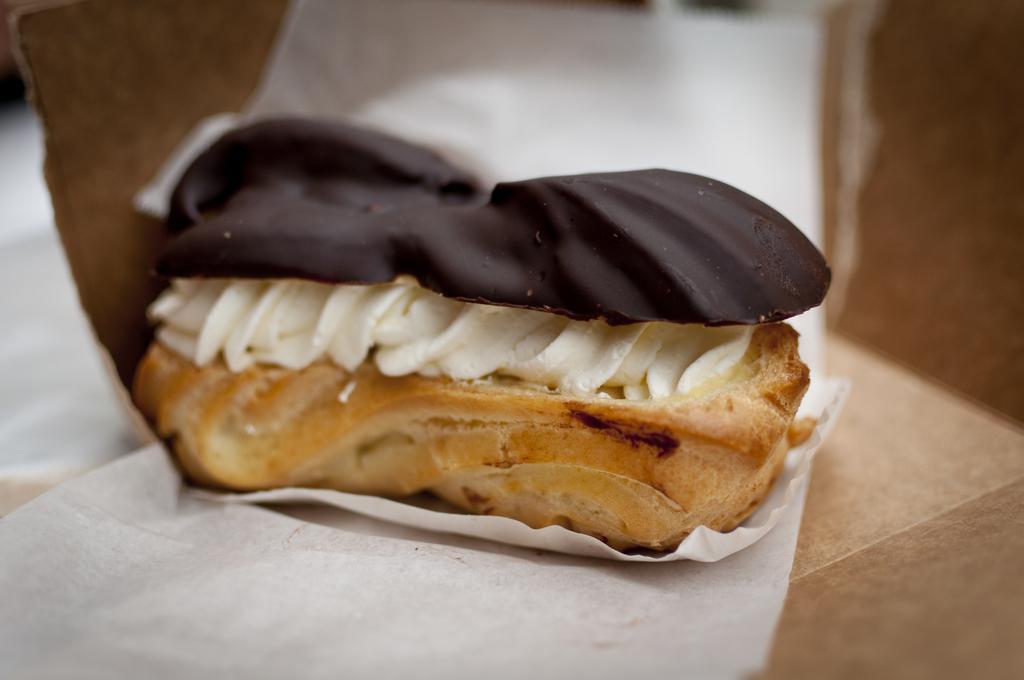How would you summarize this image in a sentence or two? In this image I can see a white colour thing and on it I can see food. I can see colour of the food is black, white and cream. I can also see this image is little bit blurry in the background. 